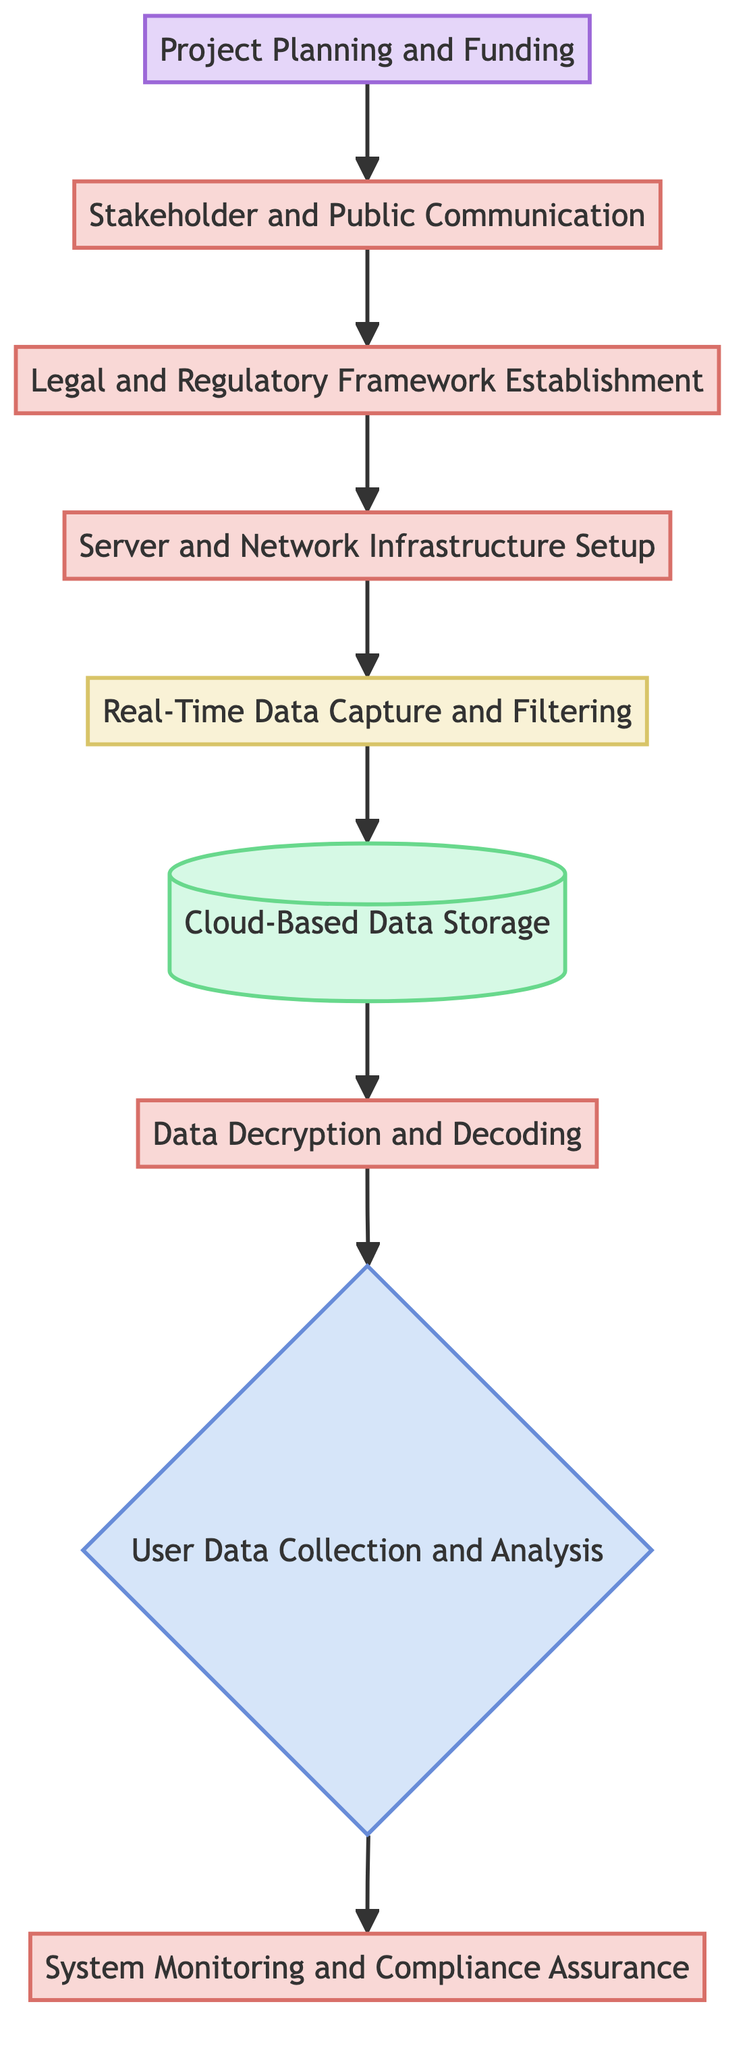What is the first step in the flowchart? The first step in the flowchart is represented by the node "Project Planning and Funding," which initiates the entire process.
Answer: Project Planning and Funding How many process nodes are present in the diagram? Identifying the nodes in the diagram shows that there are four process nodes: "System Monitoring and Compliance Assurance," "Data Decryption and Decoding," "Server and Network Infrastructure Setup," and "Legal and Regulatory Framework Establishment." Counting these yields a total of four.
Answer: 4 What type of node follows "Real-Time Data Capture and Filtering"? The node that follows "Real-Time Data Capture and Filtering" is "Cloud-Based Data Storage." The flowchart clearly shows the direct progression from one to the other with an arrow.
Answer: Cloud-Based Data Storage Which node has a decision-making element? The node that contains a decision-making element is "User Data Collection and Analysis," indicated by its shape and the label "{" which signifies a decision point in the flowchart.
Answer: User Data Collection and Analysis What is the last process node in the flow? The last process node in the flowchart is "System Monitoring and Compliance Assurance," which concludes the flow after the analysis of user data.
Answer: System Monitoring and Compliance Assurance What is the relationship between "Stakeholder and Public Communication" and "Legal and Regulatory Framework Establishment"? "Stakeholder and Public Communication" directly leads to "Legal and Regulatory Framework Establishment," as indicated by the flowchart, meaning that communication is a step that precedes and informs the establishment of the legal framework.
Answer: Leads to What is stored in the "Cloud-Based Data Storage"? The "Cloud-Based Data Storage" node refers to the storage of the data collected through the surveillance system, emphasizing secure data handling measures in this step.
Answer: Collected data What is the main goal of the "System Monitoring and Compliance Assurance" process? The main goal of this process is to ensure that all activities adhere to legal frameworks and security standards, thereby maintaining compliance throughout the operation of the surveillance system.
Answer: Compliance with legal frameworks How does the flow in this diagram progress? The flow in this diagram progresses from bottom to up, starting with the initiation phase of project planning and moving through various stages until reaching system monitoring, thereby illustrating a systematic approach to implementation.
Answer: Bottom to up 